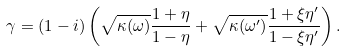Convert formula to latex. <formula><loc_0><loc_0><loc_500><loc_500>\gamma = ( 1 - i ) \left ( \sqrt { \kappa ( \omega ) } \frac { 1 + \eta } { 1 - \eta } + \sqrt { \kappa ( \omega ^ { \prime } ) } \frac { 1 + \xi \eta ^ { \prime } } { 1 - \xi \eta ^ { \prime } } \right ) .</formula> 